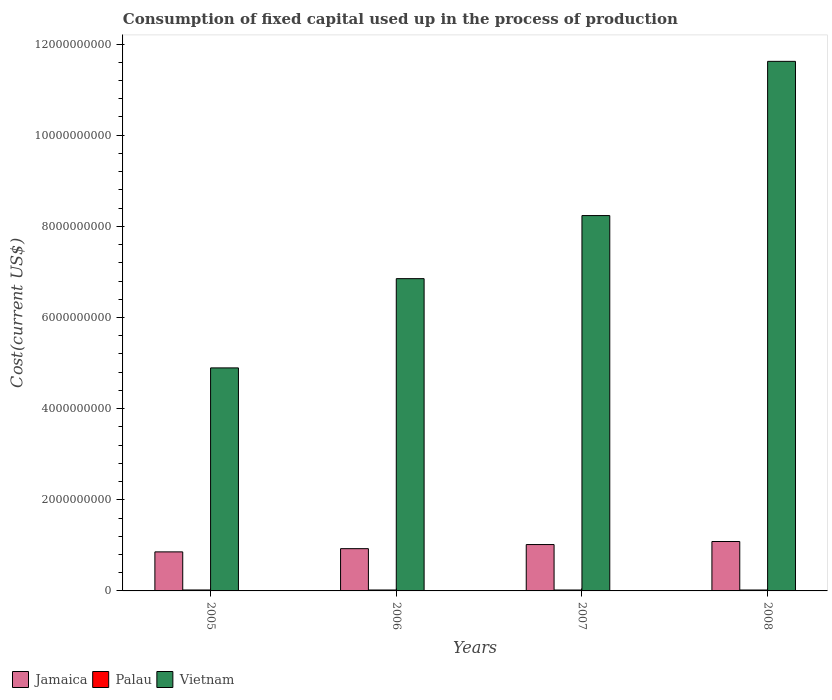Are the number of bars per tick equal to the number of legend labels?
Your response must be concise. Yes. Are the number of bars on each tick of the X-axis equal?
Your answer should be very brief. Yes. How many bars are there on the 4th tick from the left?
Provide a succinct answer. 3. What is the amount consumed in the process of production in Vietnam in 2008?
Your response must be concise. 1.16e+1. Across all years, what is the maximum amount consumed in the process of production in Palau?
Ensure brevity in your answer.  2.06e+07. Across all years, what is the minimum amount consumed in the process of production in Palau?
Offer a very short reply. 2.01e+07. In which year was the amount consumed in the process of production in Vietnam maximum?
Offer a terse response. 2008. What is the total amount consumed in the process of production in Vietnam in the graph?
Ensure brevity in your answer.  3.16e+1. What is the difference between the amount consumed in the process of production in Vietnam in 2005 and that in 2007?
Give a very brief answer. -3.34e+09. What is the difference between the amount consumed in the process of production in Jamaica in 2008 and the amount consumed in the process of production in Vietnam in 2007?
Offer a very short reply. -7.15e+09. What is the average amount consumed in the process of production in Vietnam per year?
Offer a very short reply. 7.90e+09. In the year 2007, what is the difference between the amount consumed in the process of production in Palau and amount consumed in the process of production in Vietnam?
Give a very brief answer. -8.22e+09. In how many years, is the amount consumed in the process of production in Palau greater than 2800000000 US$?
Provide a short and direct response. 0. What is the ratio of the amount consumed in the process of production in Vietnam in 2007 to that in 2008?
Your answer should be compact. 0.71. Is the difference between the amount consumed in the process of production in Palau in 2007 and 2008 greater than the difference between the amount consumed in the process of production in Vietnam in 2007 and 2008?
Your response must be concise. Yes. What is the difference between the highest and the second highest amount consumed in the process of production in Jamaica?
Ensure brevity in your answer.  6.67e+07. What is the difference between the highest and the lowest amount consumed in the process of production in Palau?
Provide a short and direct response. 4.95e+05. In how many years, is the amount consumed in the process of production in Vietnam greater than the average amount consumed in the process of production in Vietnam taken over all years?
Keep it short and to the point. 2. What does the 3rd bar from the left in 2005 represents?
Ensure brevity in your answer.  Vietnam. What does the 3rd bar from the right in 2005 represents?
Give a very brief answer. Jamaica. Is it the case that in every year, the sum of the amount consumed in the process of production in Vietnam and amount consumed in the process of production in Jamaica is greater than the amount consumed in the process of production in Palau?
Keep it short and to the point. Yes. Are all the bars in the graph horizontal?
Your response must be concise. No. What is the difference between two consecutive major ticks on the Y-axis?
Give a very brief answer. 2.00e+09. Are the values on the major ticks of Y-axis written in scientific E-notation?
Make the answer very short. No. Where does the legend appear in the graph?
Your response must be concise. Bottom left. How many legend labels are there?
Offer a terse response. 3. How are the legend labels stacked?
Your answer should be compact. Horizontal. What is the title of the graph?
Give a very brief answer. Consumption of fixed capital used up in the process of production. Does "Czech Republic" appear as one of the legend labels in the graph?
Make the answer very short. No. What is the label or title of the Y-axis?
Give a very brief answer. Cost(current US$). What is the Cost(current US$) in Jamaica in 2005?
Provide a short and direct response. 8.57e+08. What is the Cost(current US$) of Palau in 2005?
Provide a succinct answer. 2.06e+07. What is the Cost(current US$) in Vietnam in 2005?
Keep it short and to the point. 4.89e+09. What is the Cost(current US$) in Jamaica in 2006?
Ensure brevity in your answer.  9.27e+08. What is the Cost(current US$) in Palau in 2006?
Offer a terse response. 2.03e+07. What is the Cost(current US$) in Vietnam in 2006?
Ensure brevity in your answer.  6.85e+09. What is the Cost(current US$) of Jamaica in 2007?
Offer a terse response. 1.02e+09. What is the Cost(current US$) in Palau in 2007?
Your answer should be compact. 2.02e+07. What is the Cost(current US$) in Vietnam in 2007?
Keep it short and to the point. 8.24e+09. What is the Cost(current US$) in Jamaica in 2008?
Keep it short and to the point. 1.08e+09. What is the Cost(current US$) of Palau in 2008?
Offer a terse response. 2.01e+07. What is the Cost(current US$) in Vietnam in 2008?
Your answer should be compact. 1.16e+1. Across all years, what is the maximum Cost(current US$) of Jamaica?
Ensure brevity in your answer.  1.08e+09. Across all years, what is the maximum Cost(current US$) in Palau?
Ensure brevity in your answer.  2.06e+07. Across all years, what is the maximum Cost(current US$) of Vietnam?
Provide a short and direct response. 1.16e+1. Across all years, what is the minimum Cost(current US$) of Jamaica?
Provide a succinct answer. 8.57e+08. Across all years, what is the minimum Cost(current US$) of Palau?
Offer a terse response. 2.01e+07. Across all years, what is the minimum Cost(current US$) in Vietnam?
Your response must be concise. 4.89e+09. What is the total Cost(current US$) of Jamaica in the graph?
Give a very brief answer. 3.89e+09. What is the total Cost(current US$) in Palau in the graph?
Your answer should be very brief. 8.12e+07. What is the total Cost(current US$) of Vietnam in the graph?
Give a very brief answer. 3.16e+1. What is the difference between the Cost(current US$) of Jamaica in 2005 and that in 2006?
Your answer should be compact. -7.06e+07. What is the difference between the Cost(current US$) in Palau in 2005 and that in 2006?
Your answer should be compact. 3.25e+05. What is the difference between the Cost(current US$) of Vietnam in 2005 and that in 2006?
Keep it short and to the point. -1.96e+09. What is the difference between the Cost(current US$) in Jamaica in 2005 and that in 2007?
Keep it short and to the point. -1.61e+08. What is the difference between the Cost(current US$) in Palau in 2005 and that in 2007?
Your response must be concise. 4.37e+05. What is the difference between the Cost(current US$) of Vietnam in 2005 and that in 2007?
Your answer should be compact. -3.34e+09. What is the difference between the Cost(current US$) in Jamaica in 2005 and that in 2008?
Your response must be concise. -2.27e+08. What is the difference between the Cost(current US$) in Palau in 2005 and that in 2008?
Offer a terse response. 4.95e+05. What is the difference between the Cost(current US$) of Vietnam in 2005 and that in 2008?
Give a very brief answer. -6.73e+09. What is the difference between the Cost(current US$) in Jamaica in 2006 and that in 2007?
Your response must be concise. -9.01e+07. What is the difference between the Cost(current US$) of Palau in 2006 and that in 2007?
Give a very brief answer. 1.13e+05. What is the difference between the Cost(current US$) in Vietnam in 2006 and that in 2007?
Your answer should be very brief. -1.38e+09. What is the difference between the Cost(current US$) of Jamaica in 2006 and that in 2008?
Give a very brief answer. -1.57e+08. What is the difference between the Cost(current US$) in Palau in 2006 and that in 2008?
Give a very brief answer. 1.71e+05. What is the difference between the Cost(current US$) in Vietnam in 2006 and that in 2008?
Make the answer very short. -4.77e+09. What is the difference between the Cost(current US$) in Jamaica in 2007 and that in 2008?
Keep it short and to the point. -6.67e+07. What is the difference between the Cost(current US$) in Palau in 2007 and that in 2008?
Your answer should be very brief. 5.79e+04. What is the difference between the Cost(current US$) of Vietnam in 2007 and that in 2008?
Make the answer very short. -3.38e+09. What is the difference between the Cost(current US$) of Jamaica in 2005 and the Cost(current US$) of Palau in 2006?
Ensure brevity in your answer.  8.37e+08. What is the difference between the Cost(current US$) in Jamaica in 2005 and the Cost(current US$) in Vietnam in 2006?
Provide a short and direct response. -6.00e+09. What is the difference between the Cost(current US$) of Palau in 2005 and the Cost(current US$) of Vietnam in 2006?
Keep it short and to the point. -6.83e+09. What is the difference between the Cost(current US$) of Jamaica in 2005 and the Cost(current US$) of Palau in 2007?
Provide a succinct answer. 8.37e+08. What is the difference between the Cost(current US$) of Jamaica in 2005 and the Cost(current US$) of Vietnam in 2007?
Keep it short and to the point. -7.38e+09. What is the difference between the Cost(current US$) in Palau in 2005 and the Cost(current US$) in Vietnam in 2007?
Your answer should be very brief. -8.22e+09. What is the difference between the Cost(current US$) in Jamaica in 2005 and the Cost(current US$) in Palau in 2008?
Provide a short and direct response. 8.37e+08. What is the difference between the Cost(current US$) in Jamaica in 2005 and the Cost(current US$) in Vietnam in 2008?
Provide a short and direct response. -1.08e+1. What is the difference between the Cost(current US$) in Palau in 2005 and the Cost(current US$) in Vietnam in 2008?
Offer a very short reply. -1.16e+1. What is the difference between the Cost(current US$) in Jamaica in 2006 and the Cost(current US$) in Palau in 2007?
Keep it short and to the point. 9.07e+08. What is the difference between the Cost(current US$) in Jamaica in 2006 and the Cost(current US$) in Vietnam in 2007?
Ensure brevity in your answer.  -7.31e+09. What is the difference between the Cost(current US$) in Palau in 2006 and the Cost(current US$) in Vietnam in 2007?
Offer a very short reply. -8.22e+09. What is the difference between the Cost(current US$) in Jamaica in 2006 and the Cost(current US$) in Palau in 2008?
Make the answer very short. 9.07e+08. What is the difference between the Cost(current US$) in Jamaica in 2006 and the Cost(current US$) in Vietnam in 2008?
Make the answer very short. -1.07e+1. What is the difference between the Cost(current US$) in Palau in 2006 and the Cost(current US$) in Vietnam in 2008?
Provide a succinct answer. -1.16e+1. What is the difference between the Cost(current US$) in Jamaica in 2007 and the Cost(current US$) in Palau in 2008?
Provide a short and direct response. 9.97e+08. What is the difference between the Cost(current US$) of Jamaica in 2007 and the Cost(current US$) of Vietnam in 2008?
Provide a succinct answer. -1.06e+1. What is the difference between the Cost(current US$) of Palau in 2007 and the Cost(current US$) of Vietnam in 2008?
Your answer should be compact. -1.16e+1. What is the average Cost(current US$) of Jamaica per year?
Make the answer very short. 9.72e+08. What is the average Cost(current US$) in Palau per year?
Offer a terse response. 2.03e+07. What is the average Cost(current US$) of Vietnam per year?
Offer a very short reply. 7.90e+09. In the year 2005, what is the difference between the Cost(current US$) of Jamaica and Cost(current US$) of Palau?
Give a very brief answer. 8.36e+08. In the year 2005, what is the difference between the Cost(current US$) in Jamaica and Cost(current US$) in Vietnam?
Provide a short and direct response. -4.04e+09. In the year 2005, what is the difference between the Cost(current US$) in Palau and Cost(current US$) in Vietnam?
Provide a short and direct response. -4.87e+09. In the year 2006, what is the difference between the Cost(current US$) of Jamaica and Cost(current US$) of Palau?
Provide a short and direct response. 9.07e+08. In the year 2006, what is the difference between the Cost(current US$) of Jamaica and Cost(current US$) of Vietnam?
Ensure brevity in your answer.  -5.93e+09. In the year 2006, what is the difference between the Cost(current US$) of Palau and Cost(current US$) of Vietnam?
Keep it short and to the point. -6.83e+09. In the year 2007, what is the difference between the Cost(current US$) in Jamaica and Cost(current US$) in Palau?
Offer a very short reply. 9.97e+08. In the year 2007, what is the difference between the Cost(current US$) in Jamaica and Cost(current US$) in Vietnam?
Keep it short and to the point. -7.22e+09. In the year 2007, what is the difference between the Cost(current US$) in Palau and Cost(current US$) in Vietnam?
Offer a very short reply. -8.22e+09. In the year 2008, what is the difference between the Cost(current US$) of Jamaica and Cost(current US$) of Palau?
Make the answer very short. 1.06e+09. In the year 2008, what is the difference between the Cost(current US$) of Jamaica and Cost(current US$) of Vietnam?
Ensure brevity in your answer.  -1.05e+1. In the year 2008, what is the difference between the Cost(current US$) in Palau and Cost(current US$) in Vietnam?
Give a very brief answer. -1.16e+1. What is the ratio of the Cost(current US$) in Jamaica in 2005 to that in 2006?
Ensure brevity in your answer.  0.92. What is the ratio of the Cost(current US$) of Palau in 2005 to that in 2006?
Provide a short and direct response. 1.02. What is the ratio of the Cost(current US$) of Vietnam in 2005 to that in 2006?
Your answer should be very brief. 0.71. What is the ratio of the Cost(current US$) of Jamaica in 2005 to that in 2007?
Give a very brief answer. 0.84. What is the ratio of the Cost(current US$) of Palau in 2005 to that in 2007?
Keep it short and to the point. 1.02. What is the ratio of the Cost(current US$) of Vietnam in 2005 to that in 2007?
Provide a short and direct response. 0.59. What is the ratio of the Cost(current US$) of Jamaica in 2005 to that in 2008?
Your answer should be compact. 0.79. What is the ratio of the Cost(current US$) of Palau in 2005 to that in 2008?
Keep it short and to the point. 1.02. What is the ratio of the Cost(current US$) in Vietnam in 2005 to that in 2008?
Your response must be concise. 0.42. What is the ratio of the Cost(current US$) of Jamaica in 2006 to that in 2007?
Offer a very short reply. 0.91. What is the ratio of the Cost(current US$) of Palau in 2006 to that in 2007?
Offer a terse response. 1.01. What is the ratio of the Cost(current US$) of Vietnam in 2006 to that in 2007?
Make the answer very short. 0.83. What is the ratio of the Cost(current US$) of Jamaica in 2006 to that in 2008?
Provide a short and direct response. 0.86. What is the ratio of the Cost(current US$) of Palau in 2006 to that in 2008?
Keep it short and to the point. 1.01. What is the ratio of the Cost(current US$) of Vietnam in 2006 to that in 2008?
Your response must be concise. 0.59. What is the ratio of the Cost(current US$) of Jamaica in 2007 to that in 2008?
Provide a succinct answer. 0.94. What is the ratio of the Cost(current US$) in Vietnam in 2007 to that in 2008?
Keep it short and to the point. 0.71. What is the difference between the highest and the second highest Cost(current US$) in Jamaica?
Offer a terse response. 6.67e+07. What is the difference between the highest and the second highest Cost(current US$) of Palau?
Make the answer very short. 3.25e+05. What is the difference between the highest and the second highest Cost(current US$) of Vietnam?
Your answer should be very brief. 3.38e+09. What is the difference between the highest and the lowest Cost(current US$) of Jamaica?
Offer a terse response. 2.27e+08. What is the difference between the highest and the lowest Cost(current US$) of Palau?
Your answer should be very brief. 4.95e+05. What is the difference between the highest and the lowest Cost(current US$) of Vietnam?
Keep it short and to the point. 6.73e+09. 